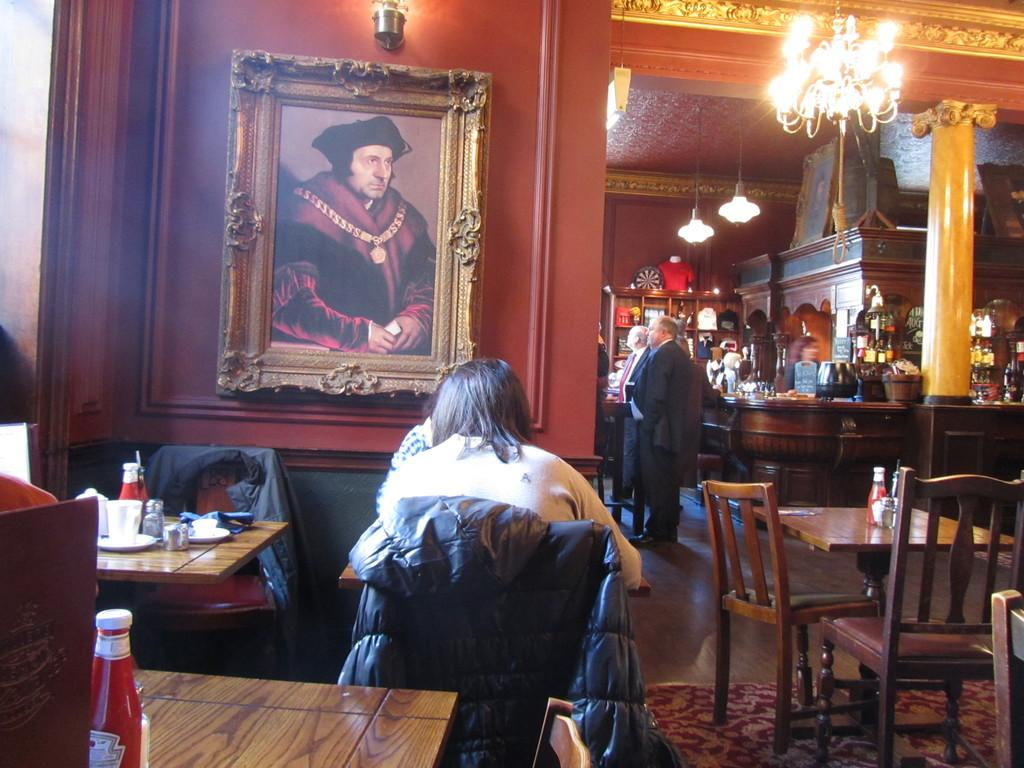How many people are in the image? There is a group of people in the image. What is the position of the person in the center of the group? The person is sitting in the center of the group. What is the person sitting on? The person is sitting on a chair. What can be seen in the background of the image? There is a photo frame, lights, and a table visible in the background. Where is the giraffe located in the image? There is no giraffe present in the image. What type of bed is visible in the image? There is no bed present in the image. 